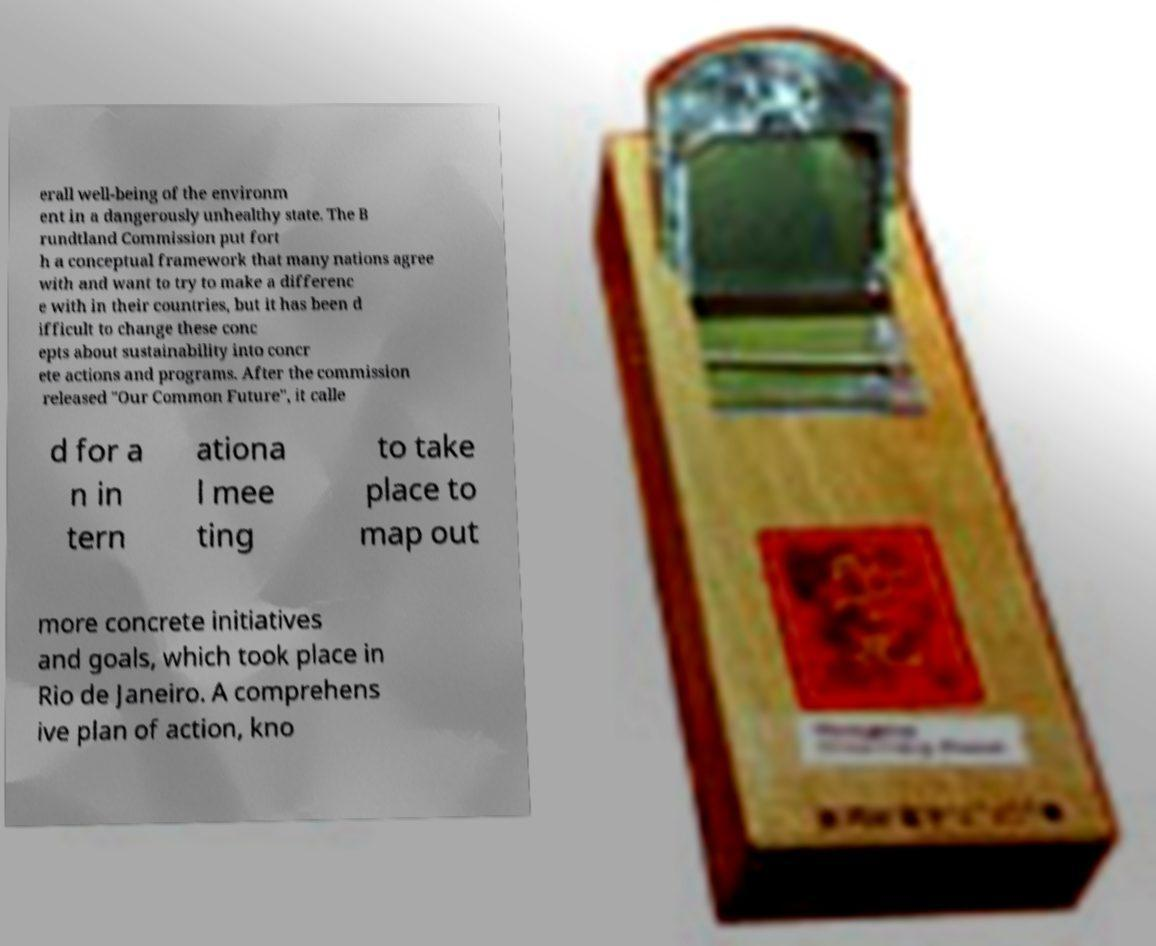I need the written content from this picture converted into text. Can you do that? erall well-being of the environm ent in a dangerously unhealthy state. The B rundtland Commission put fort h a conceptual framework that many nations agree with and want to try to make a differenc e with in their countries, but it has been d ifficult to change these conc epts about sustainability into concr ete actions and programs. After the commission released "Our Common Future", it calle d for a n in tern ationa l mee ting to take place to map out more concrete initiatives and goals, which took place in Rio de Janeiro. A comprehens ive plan of action, kno 